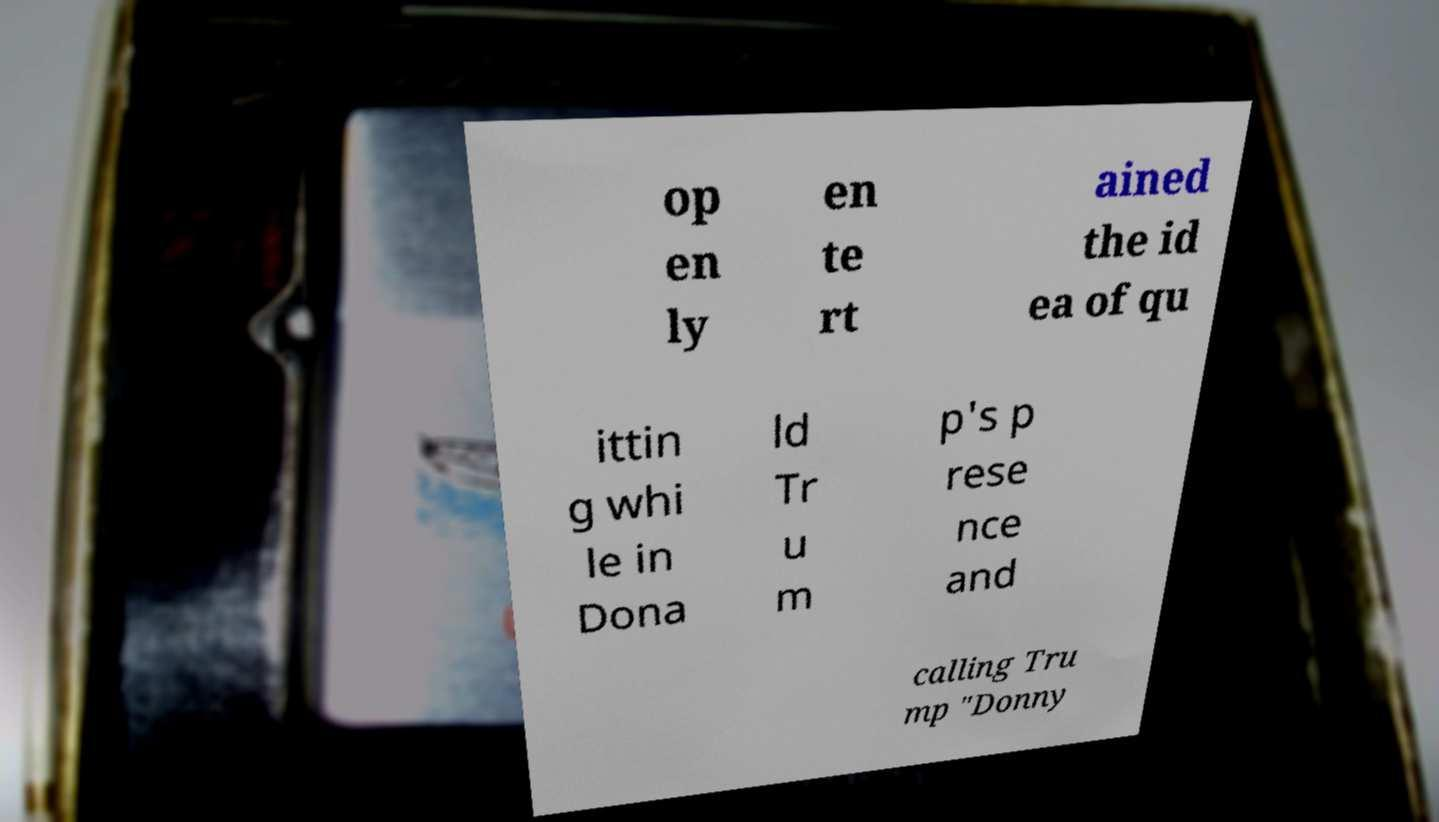There's text embedded in this image that I need extracted. Can you transcribe it verbatim? op en ly en te rt ained the id ea of qu ittin g whi le in Dona ld Tr u m p's p rese nce and calling Tru mp "Donny 